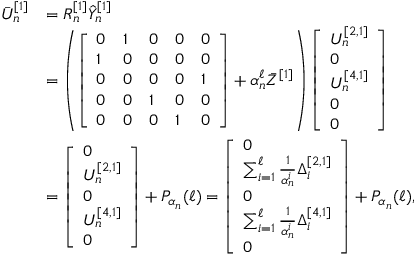<formula> <loc_0><loc_0><loc_500><loc_500>\begin{array} { r l } { \bar { U } _ { n } ^ { [ 1 ] } } & { = R _ { n } ^ { [ 1 ] } \hat { Y } _ { n } ^ { [ 1 ] } } \\ & { = \left ( \left [ \begin{array} { l l l l l } { 0 } & { 1 } & { 0 } & { 0 } & { 0 } \\ { 1 } & { 0 } & { 0 } & { 0 } & { 0 } \\ { 0 } & { 0 } & { 0 } & { 0 } & { 1 } \\ { 0 } & { 0 } & { 1 } & { 0 } & { 0 } \\ { 0 } & { 0 } & { 0 } & { 1 } & { 0 } \end{array} \right ] + \alpha _ { n } ^ { \ell } \bar { Z } ^ { [ 1 ] } \right ) \left [ \begin{array} { l } { U _ { n } ^ { [ 2 , 1 ] } } \\ { 0 } \\ { U _ { n } ^ { [ 4 , 1 ] } } \\ { 0 } \\ { 0 } \end{array} \right ] } \\ & { = \left [ \begin{array} { l } { 0 } \\ { U _ { n } ^ { [ 2 , 1 ] } } \\ { 0 } \\ { U _ { n } ^ { [ 4 , 1 ] } } \\ { 0 } \end{array} \right ] + P _ { \alpha _ { n } } ( \ell ) = \left [ \begin{array} { l } { 0 } \\ { \sum _ { i = 1 } ^ { \ell } \frac { 1 } { \alpha _ { n } ^ { i } } \Delta _ { i } ^ { [ 2 , 1 ] } } \\ { 0 } \\ { \sum _ { i = 1 } ^ { \ell } \frac { 1 } { \alpha _ { n } ^ { i } } \Delta _ { i } ^ { [ 4 , 1 ] } } \\ { 0 } \end{array} \right ] + P _ { \alpha _ { n } } ( \ell ) , } \end{array}</formula> 